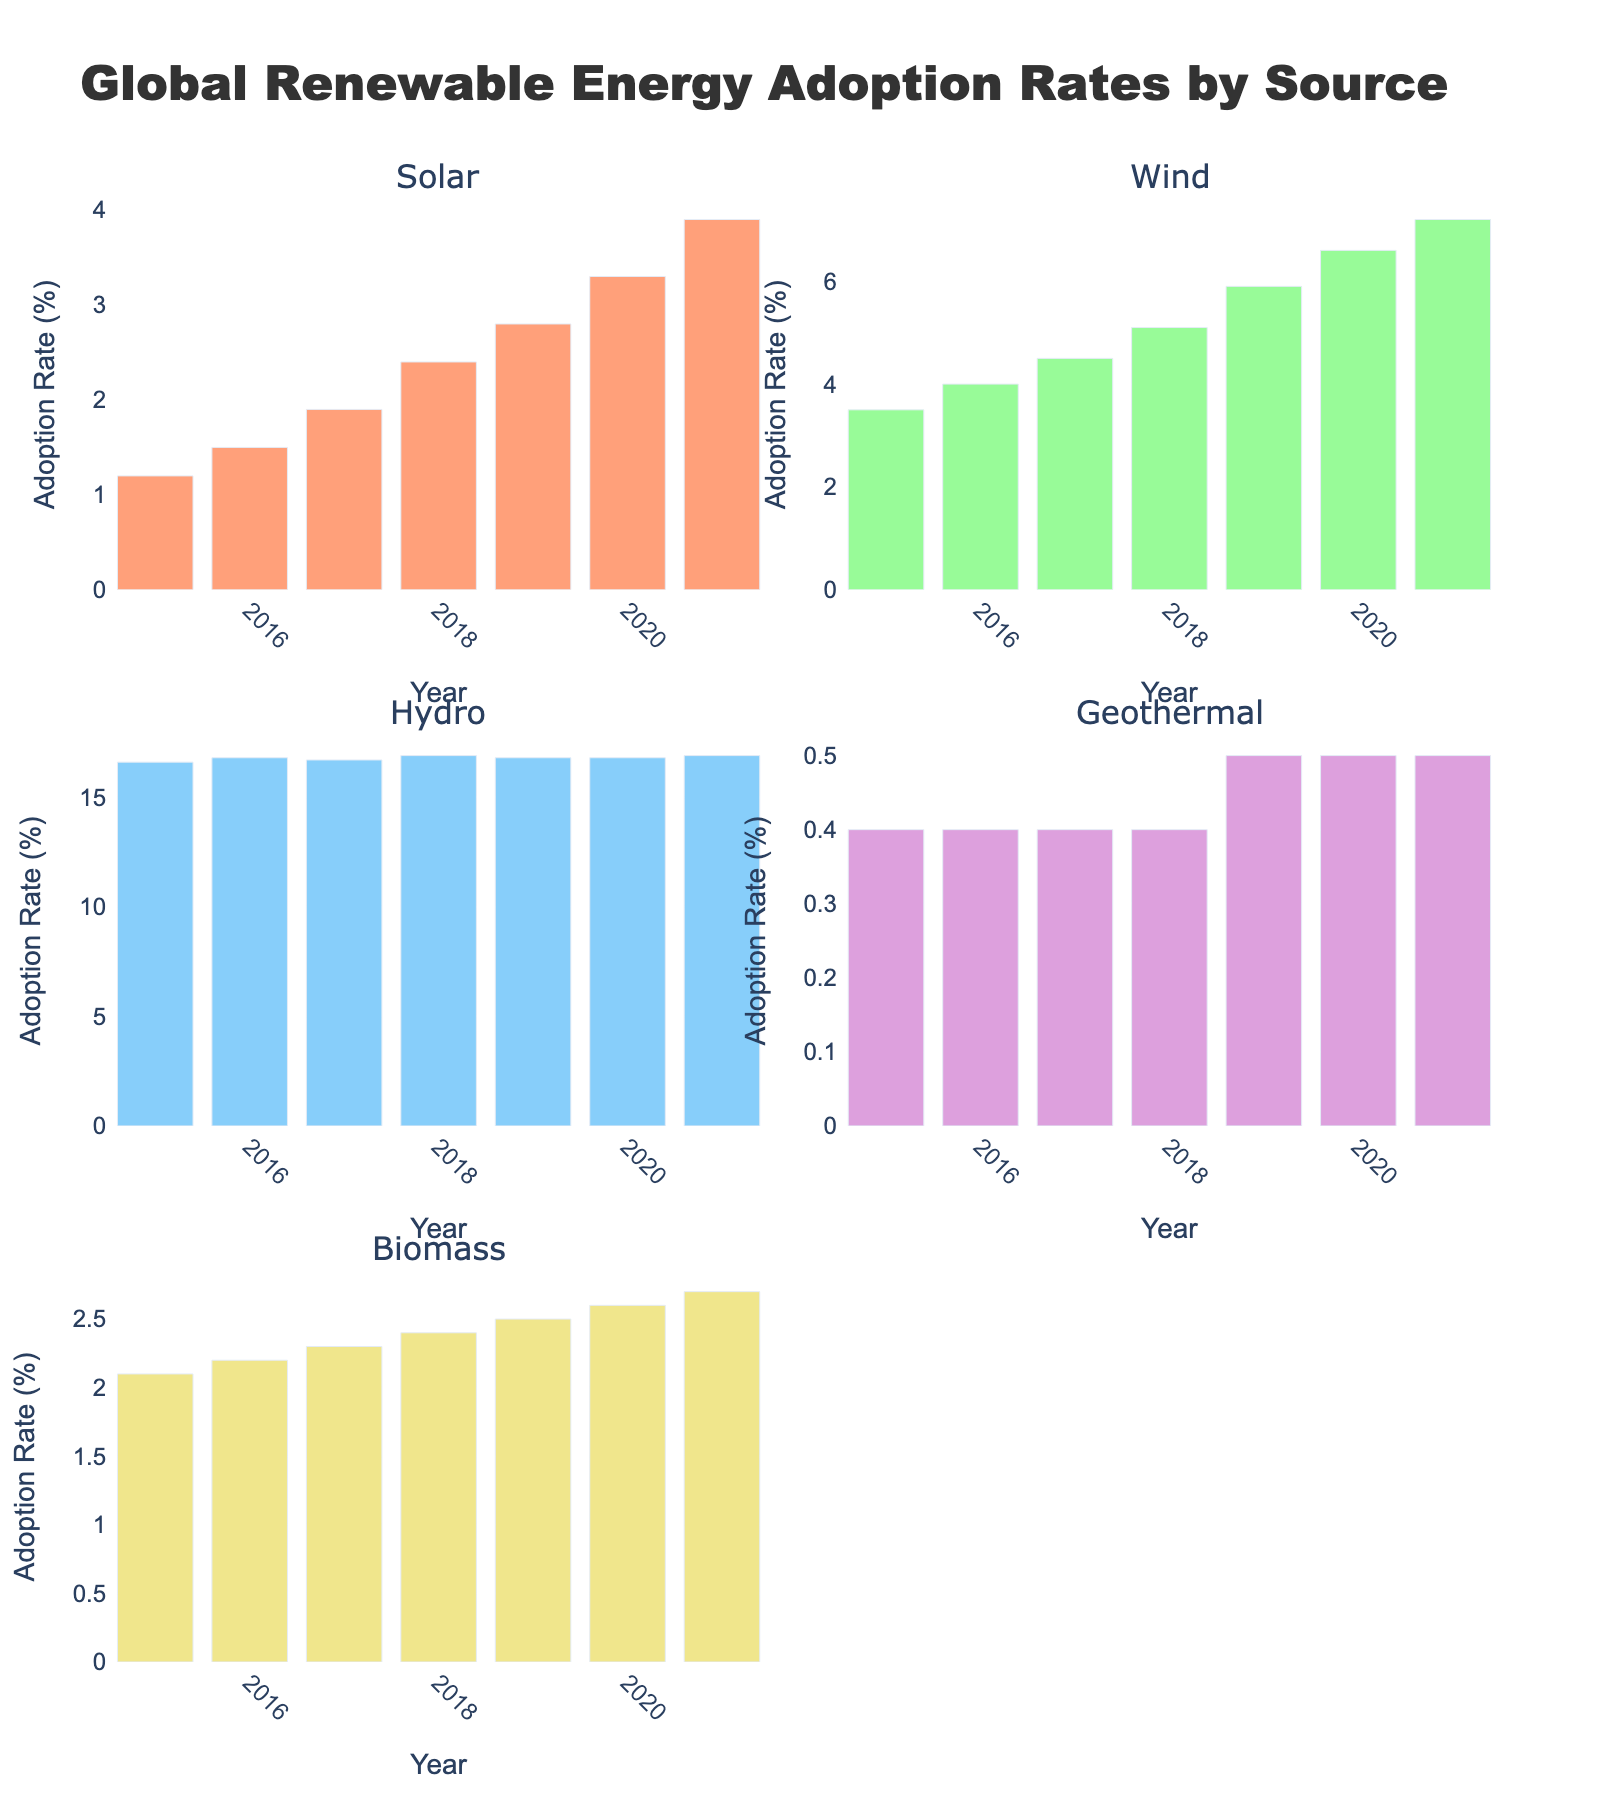what is the title of the plot? The title is usually found at the top of the figure. For this plot, it is specified in the code as "Equipment Maintenance Cost Analysis."
Answer: Equipment Maintenance Cost Analysis what are the x-axis labels in the first and second subplots? The x-axis labels are shown at the base of each subplot. In the first subplot, the x-axis is labeled "Equipment Lifespan (years)," and in the second subplot, it is labeled "Capacity (units/day)."
Answer: Equipment Lifespan (years), Capacity (units/day) how many suppliers are represented in the first subplot? Each data point corresponds to a supplier in the first subplot. There are 10 suppliers listed in the dataset, so there should be 10 data points.
Answer: 10 which supplier has the highest maintenance cost per year in the first subplot? In the first subplot, Siemens has the highest y-value, representing the highest maintenance cost at $100,000 per year.
Answer: Siemens how do the markers' sizes correlate with maintenance costs? The markers' sizes correlate with the maintenance costs; larger markers indicate higher maintenance costs.
Answer: Larger markers indicate higher costs which equipment type corresponds to the supplier with the longest lifespan? The equipment type corresponding to the supplier with the longest lifespan can be found by identifying the supplier with the maximum x-value on the first subplot. National Oilwell Varco has the longest lifespan of 20 years, and its equipment type is Storage Tank.
Answer: Storage Tank what is the relationship between maintenance cost and capacity in the second subplot? The second subplot shows no clear linear trend between maintenance cost and capacity. The costs are dispersed throughout different capacities.
Answer: No clear trend are there any data points missing from the second subplot? There is one data point missing in the second subplot. Emerson's Control System has an "N/A" value for capacity, so it is not plotted.
Answer: Yes which supplier has the largest capacity in the second subplot? Siemens' turbine has the highest capacity at 750,000 units/day, marked at the rightmost end of the second subplot.
Answer: Siemens is there a noticeable trend between equipment lifespan and maintenance costs in the first subplot? There are no clear trends between equipment lifespan and maintenance costs in the first subplot; the data points are scattered without any linear correlation.
Answer: No clear trend 